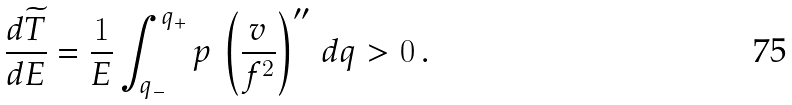Convert formula to latex. <formula><loc_0><loc_0><loc_500><loc_500>\frac { d \widetilde { T } } { d E } = \frac { 1 } { E } \int _ { q _ { - } } ^ { q _ { + } } p \, \left ( \frac { v } { f ^ { 2 } } \right ) ^ { \prime \prime } \, d q > 0 \, .</formula> 